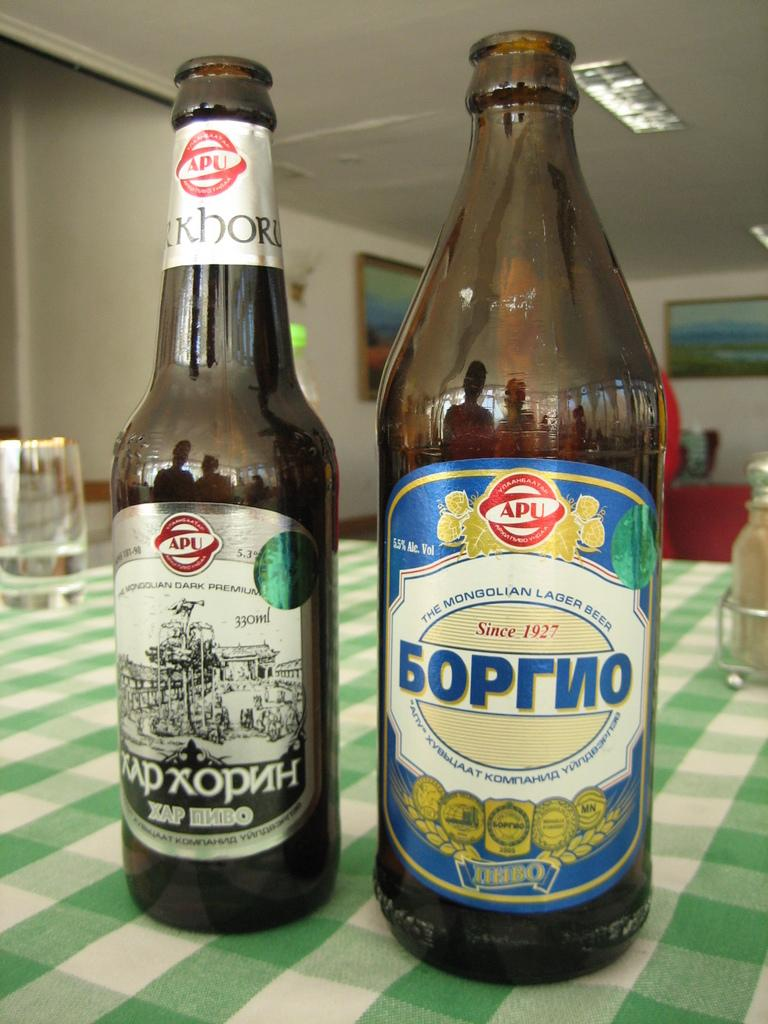Provide a one-sentence caption for the provided image. The beer was made by "The Mongolian Lager Beer" company. 